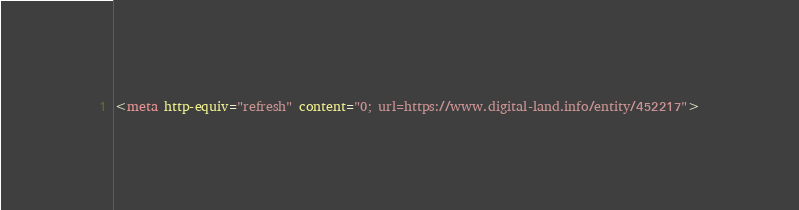<code> <loc_0><loc_0><loc_500><loc_500><_HTML_><meta http-equiv="refresh" content="0; url=https://www.digital-land.info/entity/452217"></code> 